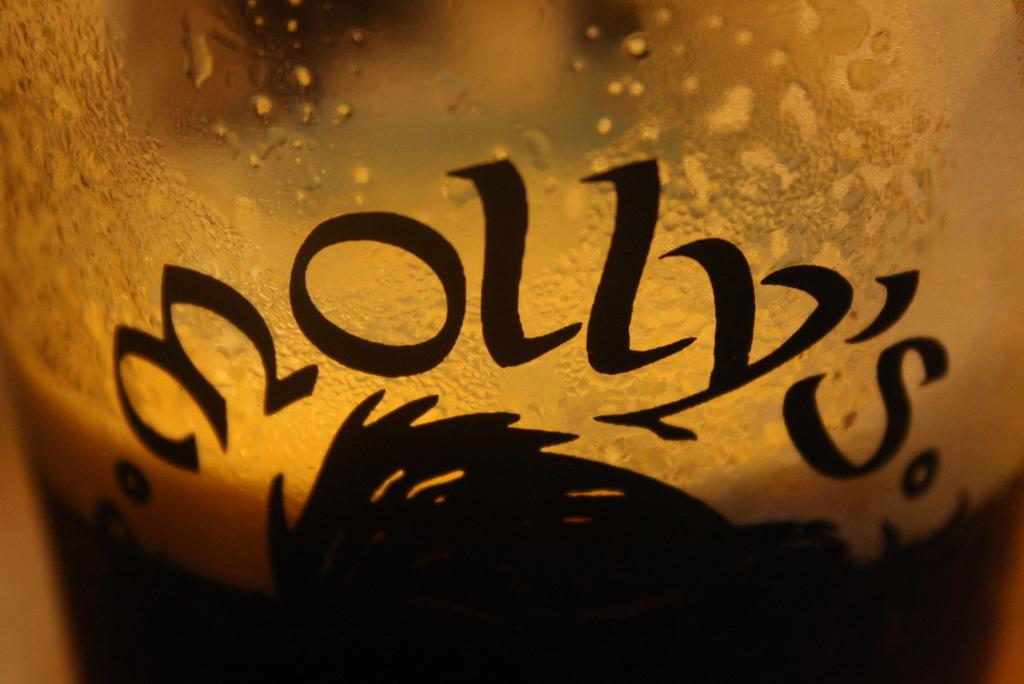<image>
Present a compact description of the photo's key features. a close up of a Molly's bar glass half full of ale 